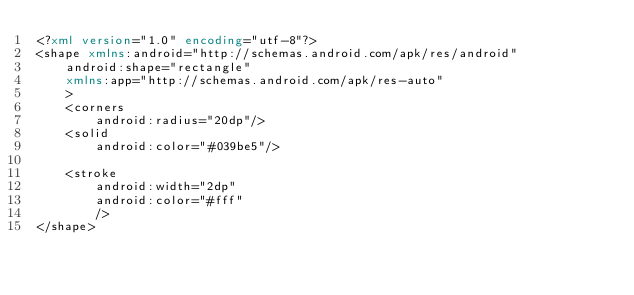<code> <loc_0><loc_0><loc_500><loc_500><_XML_><?xml version="1.0" encoding="utf-8"?>
<shape xmlns:android="http://schemas.android.com/apk/res/android"
    android:shape="rectangle"
    xmlns:app="http://schemas.android.com/apk/res-auto"
    >
    <corners
        android:radius="20dp"/>
    <solid
        android:color="#039be5"/>

    <stroke
        android:width="2dp"
        android:color="#fff"
        />
</shape></code> 